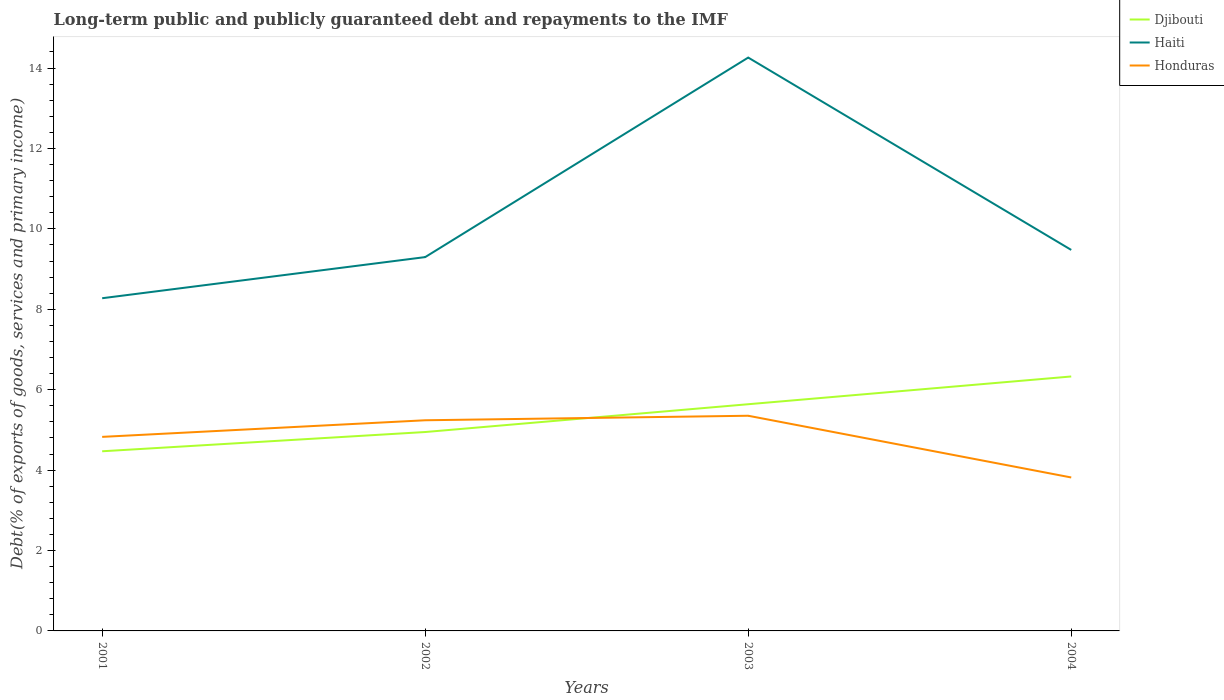How many different coloured lines are there?
Ensure brevity in your answer.  3. Does the line corresponding to Haiti intersect with the line corresponding to Honduras?
Your answer should be compact. No. Across all years, what is the maximum debt and repayments in Haiti?
Provide a short and direct response. 8.28. In which year was the debt and repayments in Djibouti maximum?
Keep it short and to the point. 2001. What is the total debt and repayments in Haiti in the graph?
Your answer should be very brief. -1.2. What is the difference between the highest and the second highest debt and repayments in Djibouti?
Offer a very short reply. 1.86. How many lines are there?
Offer a terse response. 3. How many years are there in the graph?
Provide a succinct answer. 4. Are the values on the major ticks of Y-axis written in scientific E-notation?
Ensure brevity in your answer.  No. Where does the legend appear in the graph?
Keep it short and to the point. Top right. What is the title of the graph?
Your answer should be very brief. Long-term public and publicly guaranteed debt and repayments to the IMF. Does "South Asia" appear as one of the legend labels in the graph?
Offer a terse response. No. What is the label or title of the X-axis?
Your answer should be very brief. Years. What is the label or title of the Y-axis?
Your answer should be compact. Debt(% of exports of goods, services and primary income). What is the Debt(% of exports of goods, services and primary income) in Djibouti in 2001?
Make the answer very short. 4.47. What is the Debt(% of exports of goods, services and primary income) in Haiti in 2001?
Make the answer very short. 8.28. What is the Debt(% of exports of goods, services and primary income) in Honduras in 2001?
Offer a terse response. 4.83. What is the Debt(% of exports of goods, services and primary income) of Djibouti in 2002?
Offer a very short reply. 4.95. What is the Debt(% of exports of goods, services and primary income) of Haiti in 2002?
Give a very brief answer. 9.3. What is the Debt(% of exports of goods, services and primary income) of Honduras in 2002?
Your answer should be compact. 5.24. What is the Debt(% of exports of goods, services and primary income) in Djibouti in 2003?
Your answer should be compact. 5.64. What is the Debt(% of exports of goods, services and primary income) in Haiti in 2003?
Keep it short and to the point. 14.26. What is the Debt(% of exports of goods, services and primary income) in Honduras in 2003?
Your answer should be compact. 5.35. What is the Debt(% of exports of goods, services and primary income) of Djibouti in 2004?
Ensure brevity in your answer.  6.33. What is the Debt(% of exports of goods, services and primary income) of Haiti in 2004?
Your answer should be very brief. 9.48. What is the Debt(% of exports of goods, services and primary income) in Honduras in 2004?
Make the answer very short. 3.82. Across all years, what is the maximum Debt(% of exports of goods, services and primary income) of Djibouti?
Make the answer very short. 6.33. Across all years, what is the maximum Debt(% of exports of goods, services and primary income) of Haiti?
Keep it short and to the point. 14.26. Across all years, what is the maximum Debt(% of exports of goods, services and primary income) of Honduras?
Ensure brevity in your answer.  5.35. Across all years, what is the minimum Debt(% of exports of goods, services and primary income) in Djibouti?
Provide a succinct answer. 4.47. Across all years, what is the minimum Debt(% of exports of goods, services and primary income) of Haiti?
Your answer should be very brief. 8.28. Across all years, what is the minimum Debt(% of exports of goods, services and primary income) of Honduras?
Your answer should be compact. 3.82. What is the total Debt(% of exports of goods, services and primary income) in Djibouti in the graph?
Provide a succinct answer. 21.38. What is the total Debt(% of exports of goods, services and primary income) in Haiti in the graph?
Give a very brief answer. 41.31. What is the total Debt(% of exports of goods, services and primary income) in Honduras in the graph?
Keep it short and to the point. 19.24. What is the difference between the Debt(% of exports of goods, services and primary income) of Djibouti in 2001 and that in 2002?
Keep it short and to the point. -0.48. What is the difference between the Debt(% of exports of goods, services and primary income) in Haiti in 2001 and that in 2002?
Ensure brevity in your answer.  -1.02. What is the difference between the Debt(% of exports of goods, services and primary income) of Honduras in 2001 and that in 2002?
Provide a succinct answer. -0.41. What is the difference between the Debt(% of exports of goods, services and primary income) in Djibouti in 2001 and that in 2003?
Give a very brief answer. -1.17. What is the difference between the Debt(% of exports of goods, services and primary income) in Haiti in 2001 and that in 2003?
Your response must be concise. -5.99. What is the difference between the Debt(% of exports of goods, services and primary income) in Honduras in 2001 and that in 2003?
Your answer should be very brief. -0.53. What is the difference between the Debt(% of exports of goods, services and primary income) in Djibouti in 2001 and that in 2004?
Your answer should be compact. -1.86. What is the difference between the Debt(% of exports of goods, services and primary income) of Haiti in 2001 and that in 2004?
Provide a short and direct response. -1.2. What is the difference between the Debt(% of exports of goods, services and primary income) of Honduras in 2001 and that in 2004?
Keep it short and to the point. 1.01. What is the difference between the Debt(% of exports of goods, services and primary income) of Djibouti in 2002 and that in 2003?
Offer a terse response. -0.69. What is the difference between the Debt(% of exports of goods, services and primary income) in Haiti in 2002 and that in 2003?
Your response must be concise. -4.96. What is the difference between the Debt(% of exports of goods, services and primary income) of Honduras in 2002 and that in 2003?
Make the answer very short. -0.11. What is the difference between the Debt(% of exports of goods, services and primary income) in Djibouti in 2002 and that in 2004?
Make the answer very short. -1.38. What is the difference between the Debt(% of exports of goods, services and primary income) of Haiti in 2002 and that in 2004?
Give a very brief answer. -0.18. What is the difference between the Debt(% of exports of goods, services and primary income) in Honduras in 2002 and that in 2004?
Your answer should be compact. 1.42. What is the difference between the Debt(% of exports of goods, services and primary income) of Djibouti in 2003 and that in 2004?
Ensure brevity in your answer.  -0.69. What is the difference between the Debt(% of exports of goods, services and primary income) of Haiti in 2003 and that in 2004?
Your response must be concise. 4.78. What is the difference between the Debt(% of exports of goods, services and primary income) in Honduras in 2003 and that in 2004?
Provide a short and direct response. 1.54. What is the difference between the Debt(% of exports of goods, services and primary income) of Djibouti in 2001 and the Debt(% of exports of goods, services and primary income) of Haiti in 2002?
Offer a terse response. -4.83. What is the difference between the Debt(% of exports of goods, services and primary income) of Djibouti in 2001 and the Debt(% of exports of goods, services and primary income) of Honduras in 2002?
Your response must be concise. -0.77. What is the difference between the Debt(% of exports of goods, services and primary income) of Haiti in 2001 and the Debt(% of exports of goods, services and primary income) of Honduras in 2002?
Your answer should be very brief. 3.04. What is the difference between the Debt(% of exports of goods, services and primary income) of Djibouti in 2001 and the Debt(% of exports of goods, services and primary income) of Haiti in 2003?
Your answer should be compact. -9.79. What is the difference between the Debt(% of exports of goods, services and primary income) in Djibouti in 2001 and the Debt(% of exports of goods, services and primary income) in Honduras in 2003?
Offer a very short reply. -0.88. What is the difference between the Debt(% of exports of goods, services and primary income) of Haiti in 2001 and the Debt(% of exports of goods, services and primary income) of Honduras in 2003?
Provide a succinct answer. 2.92. What is the difference between the Debt(% of exports of goods, services and primary income) of Djibouti in 2001 and the Debt(% of exports of goods, services and primary income) of Haiti in 2004?
Make the answer very short. -5.01. What is the difference between the Debt(% of exports of goods, services and primary income) in Djibouti in 2001 and the Debt(% of exports of goods, services and primary income) in Honduras in 2004?
Provide a succinct answer. 0.65. What is the difference between the Debt(% of exports of goods, services and primary income) of Haiti in 2001 and the Debt(% of exports of goods, services and primary income) of Honduras in 2004?
Provide a short and direct response. 4.46. What is the difference between the Debt(% of exports of goods, services and primary income) of Djibouti in 2002 and the Debt(% of exports of goods, services and primary income) of Haiti in 2003?
Give a very brief answer. -9.31. What is the difference between the Debt(% of exports of goods, services and primary income) of Djibouti in 2002 and the Debt(% of exports of goods, services and primary income) of Honduras in 2003?
Your answer should be very brief. -0.4. What is the difference between the Debt(% of exports of goods, services and primary income) in Haiti in 2002 and the Debt(% of exports of goods, services and primary income) in Honduras in 2003?
Keep it short and to the point. 3.95. What is the difference between the Debt(% of exports of goods, services and primary income) of Djibouti in 2002 and the Debt(% of exports of goods, services and primary income) of Haiti in 2004?
Your answer should be very brief. -4.53. What is the difference between the Debt(% of exports of goods, services and primary income) of Djibouti in 2002 and the Debt(% of exports of goods, services and primary income) of Honduras in 2004?
Make the answer very short. 1.13. What is the difference between the Debt(% of exports of goods, services and primary income) in Haiti in 2002 and the Debt(% of exports of goods, services and primary income) in Honduras in 2004?
Your answer should be compact. 5.48. What is the difference between the Debt(% of exports of goods, services and primary income) in Djibouti in 2003 and the Debt(% of exports of goods, services and primary income) in Haiti in 2004?
Keep it short and to the point. -3.84. What is the difference between the Debt(% of exports of goods, services and primary income) in Djibouti in 2003 and the Debt(% of exports of goods, services and primary income) in Honduras in 2004?
Give a very brief answer. 1.82. What is the difference between the Debt(% of exports of goods, services and primary income) of Haiti in 2003 and the Debt(% of exports of goods, services and primary income) of Honduras in 2004?
Provide a short and direct response. 10.44. What is the average Debt(% of exports of goods, services and primary income) of Djibouti per year?
Offer a terse response. 5.35. What is the average Debt(% of exports of goods, services and primary income) of Haiti per year?
Offer a very short reply. 10.33. What is the average Debt(% of exports of goods, services and primary income) of Honduras per year?
Your answer should be very brief. 4.81. In the year 2001, what is the difference between the Debt(% of exports of goods, services and primary income) of Djibouti and Debt(% of exports of goods, services and primary income) of Haiti?
Your response must be concise. -3.81. In the year 2001, what is the difference between the Debt(% of exports of goods, services and primary income) in Djibouti and Debt(% of exports of goods, services and primary income) in Honduras?
Your response must be concise. -0.36. In the year 2001, what is the difference between the Debt(% of exports of goods, services and primary income) of Haiti and Debt(% of exports of goods, services and primary income) of Honduras?
Provide a succinct answer. 3.45. In the year 2002, what is the difference between the Debt(% of exports of goods, services and primary income) of Djibouti and Debt(% of exports of goods, services and primary income) of Haiti?
Ensure brevity in your answer.  -4.35. In the year 2002, what is the difference between the Debt(% of exports of goods, services and primary income) in Djibouti and Debt(% of exports of goods, services and primary income) in Honduras?
Provide a succinct answer. -0.29. In the year 2002, what is the difference between the Debt(% of exports of goods, services and primary income) in Haiti and Debt(% of exports of goods, services and primary income) in Honduras?
Provide a succinct answer. 4.06. In the year 2003, what is the difference between the Debt(% of exports of goods, services and primary income) of Djibouti and Debt(% of exports of goods, services and primary income) of Haiti?
Provide a succinct answer. -8.62. In the year 2003, what is the difference between the Debt(% of exports of goods, services and primary income) in Djibouti and Debt(% of exports of goods, services and primary income) in Honduras?
Offer a very short reply. 0.29. In the year 2003, what is the difference between the Debt(% of exports of goods, services and primary income) in Haiti and Debt(% of exports of goods, services and primary income) in Honduras?
Your response must be concise. 8.91. In the year 2004, what is the difference between the Debt(% of exports of goods, services and primary income) of Djibouti and Debt(% of exports of goods, services and primary income) of Haiti?
Offer a very short reply. -3.15. In the year 2004, what is the difference between the Debt(% of exports of goods, services and primary income) in Djibouti and Debt(% of exports of goods, services and primary income) in Honduras?
Keep it short and to the point. 2.51. In the year 2004, what is the difference between the Debt(% of exports of goods, services and primary income) of Haiti and Debt(% of exports of goods, services and primary income) of Honduras?
Make the answer very short. 5.66. What is the ratio of the Debt(% of exports of goods, services and primary income) in Djibouti in 2001 to that in 2002?
Your response must be concise. 0.9. What is the ratio of the Debt(% of exports of goods, services and primary income) in Haiti in 2001 to that in 2002?
Your response must be concise. 0.89. What is the ratio of the Debt(% of exports of goods, services and primary income) of Honduras in 2001 to that in 2002?
Give a very brief answer. 0.92. What is the ratio of the Debt(% of exports of goods, services and primary income) of Djibouti in 2001 to that in 2003?
Your response must be concise. 0.79. What is the ratio of the Debt(% of exports of goods, services and primary income) in Haiti in 2001 to that in 2003?
Your response must be concise. 0.58. What is the ratio of the Debt(% of exports of goods, services and primary income) in Honduras in 2001 to that in 2003?
Give a very brief answer. 0.9. What is the ratio of the Debt(% of exports of goods, services and primary income) of Djibouti in 2001 to that in 2004?
Give a very brief answer. 0.71. What is the ratio of the Debt(% of exports of goods, services and primary income) of Haiti in 2001 to that in 2004?
Offer a terse response. 0.87. What is the ratio of the Debt(% of exports of goods, services and primary income) of Honduras in 2001 to that in 2004?
Your response must be concise. 1.26. What is the ratio of the Debt(% of exports of goods, services and primary income) of Djibouti in 2002 to that in 2003?
Your answer should be very brief. 0.88. What is the ratio of the Debt(% of exports of goods, services and primary income) in Haiti in 2002 to that in 2003?
Offer a very short reply. 0.65. What is the ratio of the Debt(% of exports of goods, services and primary income) of Honduras in 2002 to that in 2003?
Give a very brief answer. 0.98. What is the ratio of the Debt(% of exports of goods, services and primary income) in Djibouti in 2002 to that in 2004?
Keep it short and to the point. 0.78. What is the ratio of the Debt(% of exports of goods, services and primary income) in Haiti in 2002 to that in 2004?
Offer a very short reply. 0.98. What is the ratio of the Debt(% of exports of goods, services and primary income) of Honduras in 2002 to that in 2004?
Make the answer very short. 1.37. What is the ratio of the Debt(% of exports of goods, services and primary income) in Djibouti in 2003 to that in 2004?
Give a very brief answer. 0.89. What is the ratio of the Debt(% of exports of goods, services and primary income) in Haiti in 2003 to that in 2004?
Provide a succinct answer. 1.5. What is the ratio of the Debt(% of exports of goods, services and primary income) of Honduras in 2003 to that in 2004?
Provide a short and direct response. 1.4. What is the difference between the highest and the second highest Debt(% of exports of goods, services and primary income) of Djibouti?
Keep it short and to the point. 0.69. What is the difference between the highest and the second highest Debt(% of exports of goods, services and primary income) of Haiti?
Your response must be concise. 4.78. What is the difference between the highest and the second highest Debt(% of exports of goods, services and primary income) of Honduras?
Provide a short and direct response. 0.11. What is the difference between the highest and the lowest Debt(% of exports of goods, services and primary income) of Djibouti?
Your response must be concise. 1.86. What is the difference between the highest and the lowest Debt(% of exports of goods, services and primary income) of Haiti?
Give a very brief answer. 5.99. What is the difference between the highest and the lowest Debt(% of exports of goods, services and primary income) of Honduras?
Keep it short and to the point. 1.54. 